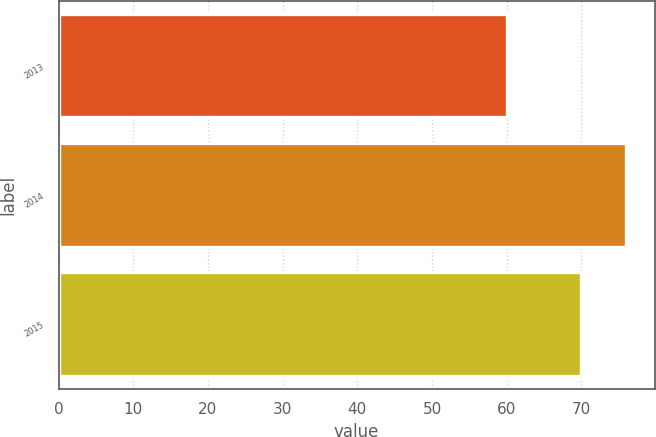Convert chart to OTSL. <chart><loc_0><loc_0><loc_500><loc_500><bar_chart><fcel>2013<fcel>2014<fcel>2015<nl><fcel>60<fcel>76<fcel>70<nl></chart> 